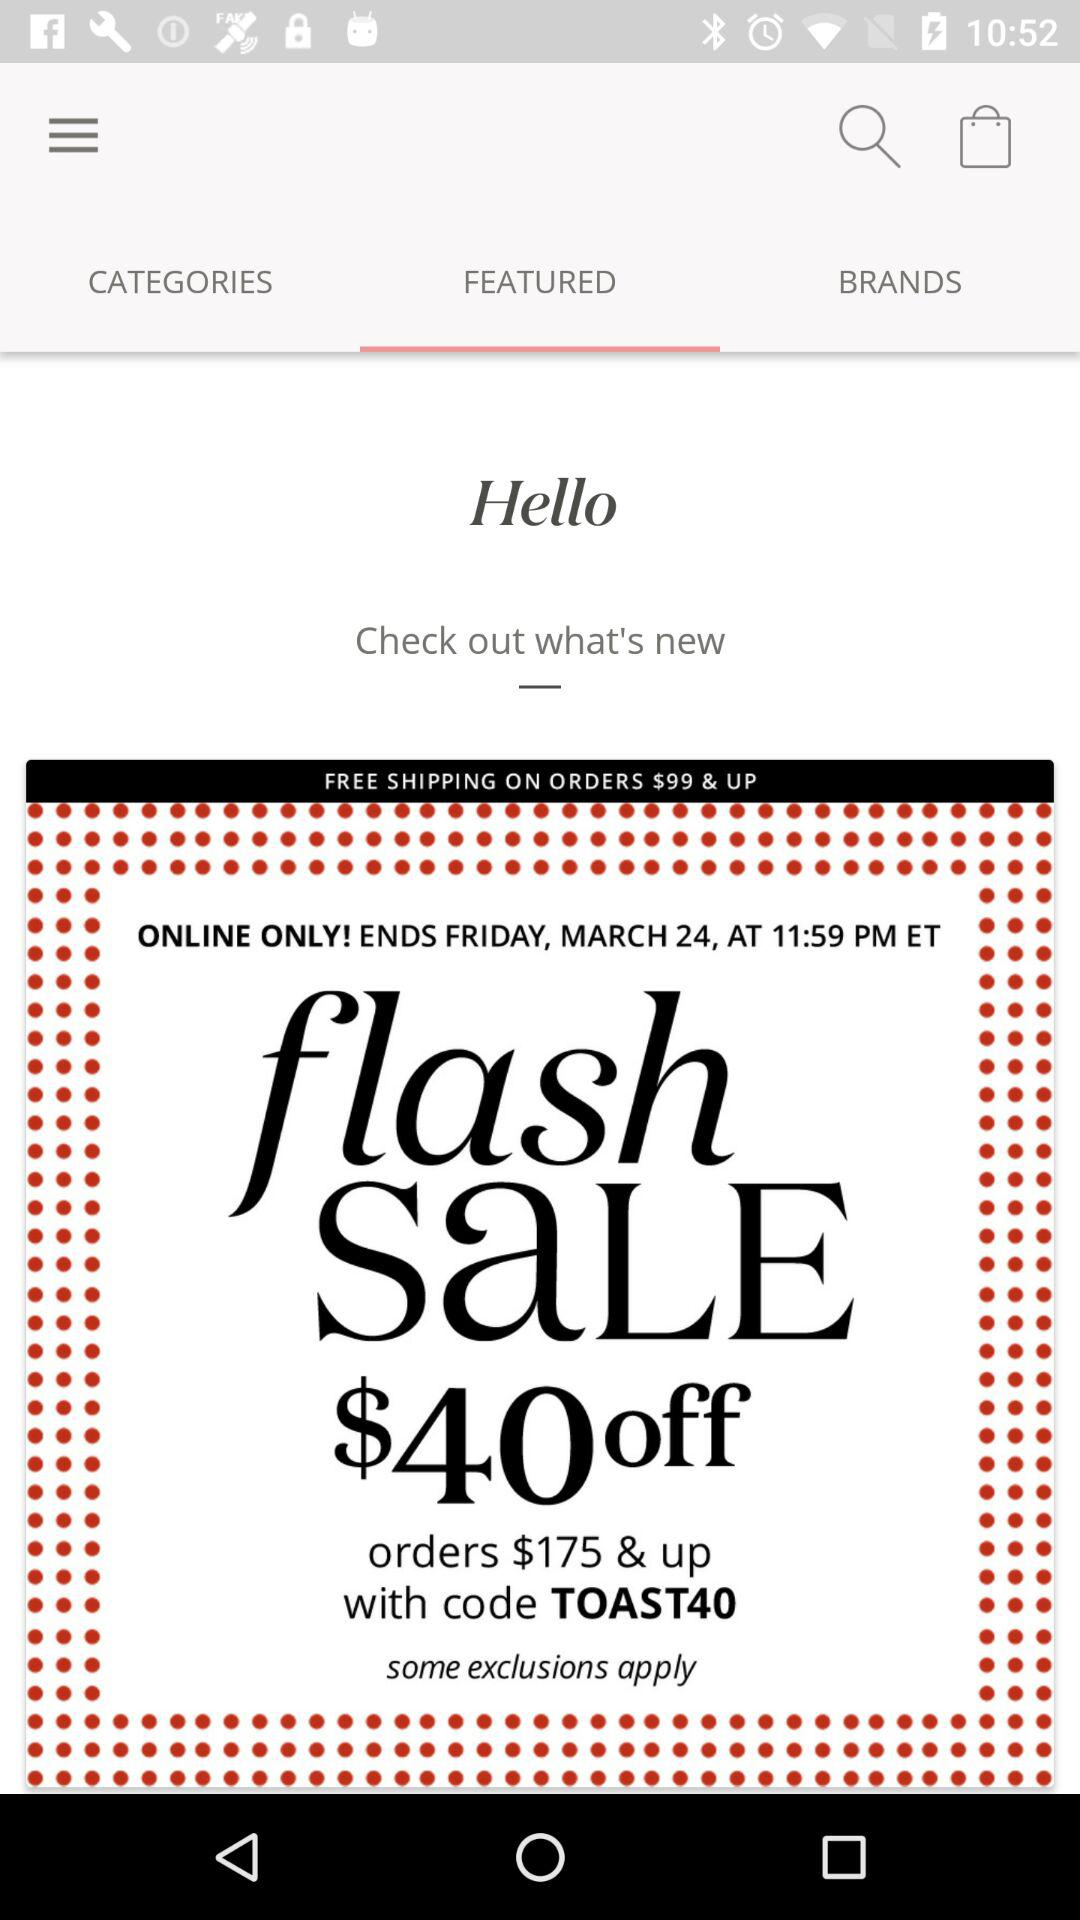How much of a discount can I get in a flash sale? You can get $40 off. 